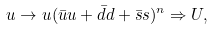Convert formula to latex. <formula><loc_0><loc_0><loc_500><loc_500>u \rightarrow u ( \bar { u } u + \bar { d } d + \bar { s } s ) ^ { n } \Rightarrow U ,</formula> 